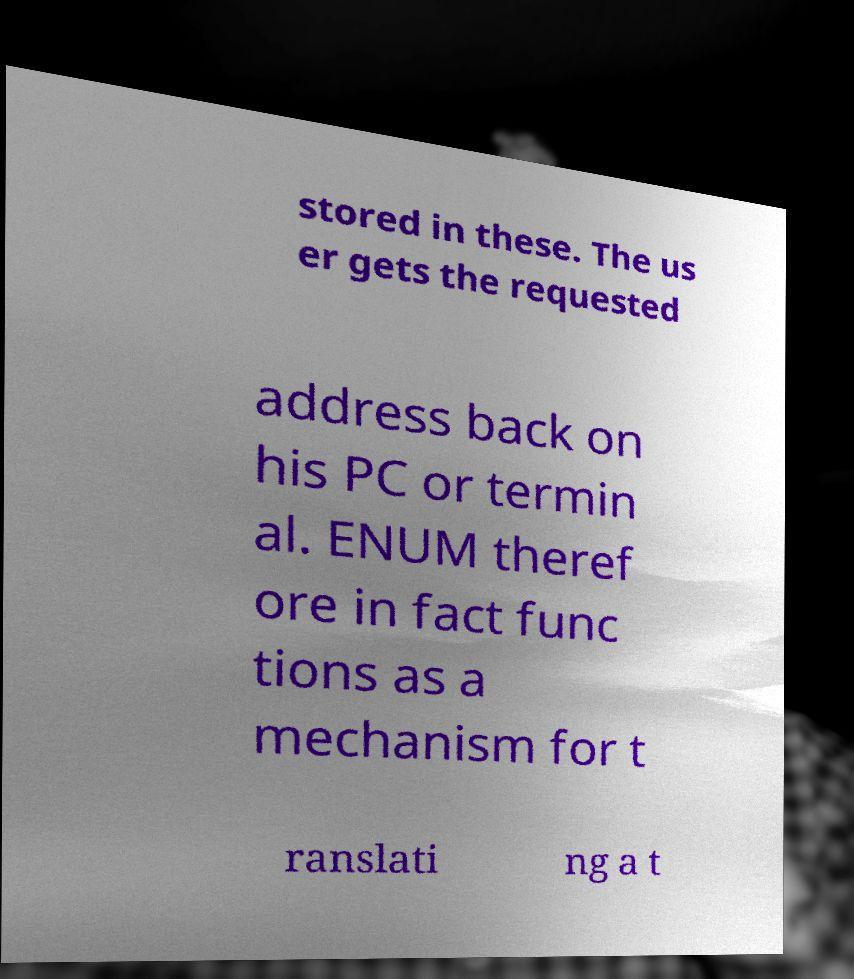Could you assist in decoding the text presented in this image and type it out clearly? stored in these. The us er gets the requested address back on his PC or termin al. ENUM theref ore in fact func tions as a mechanism for t ranslati ng a t 